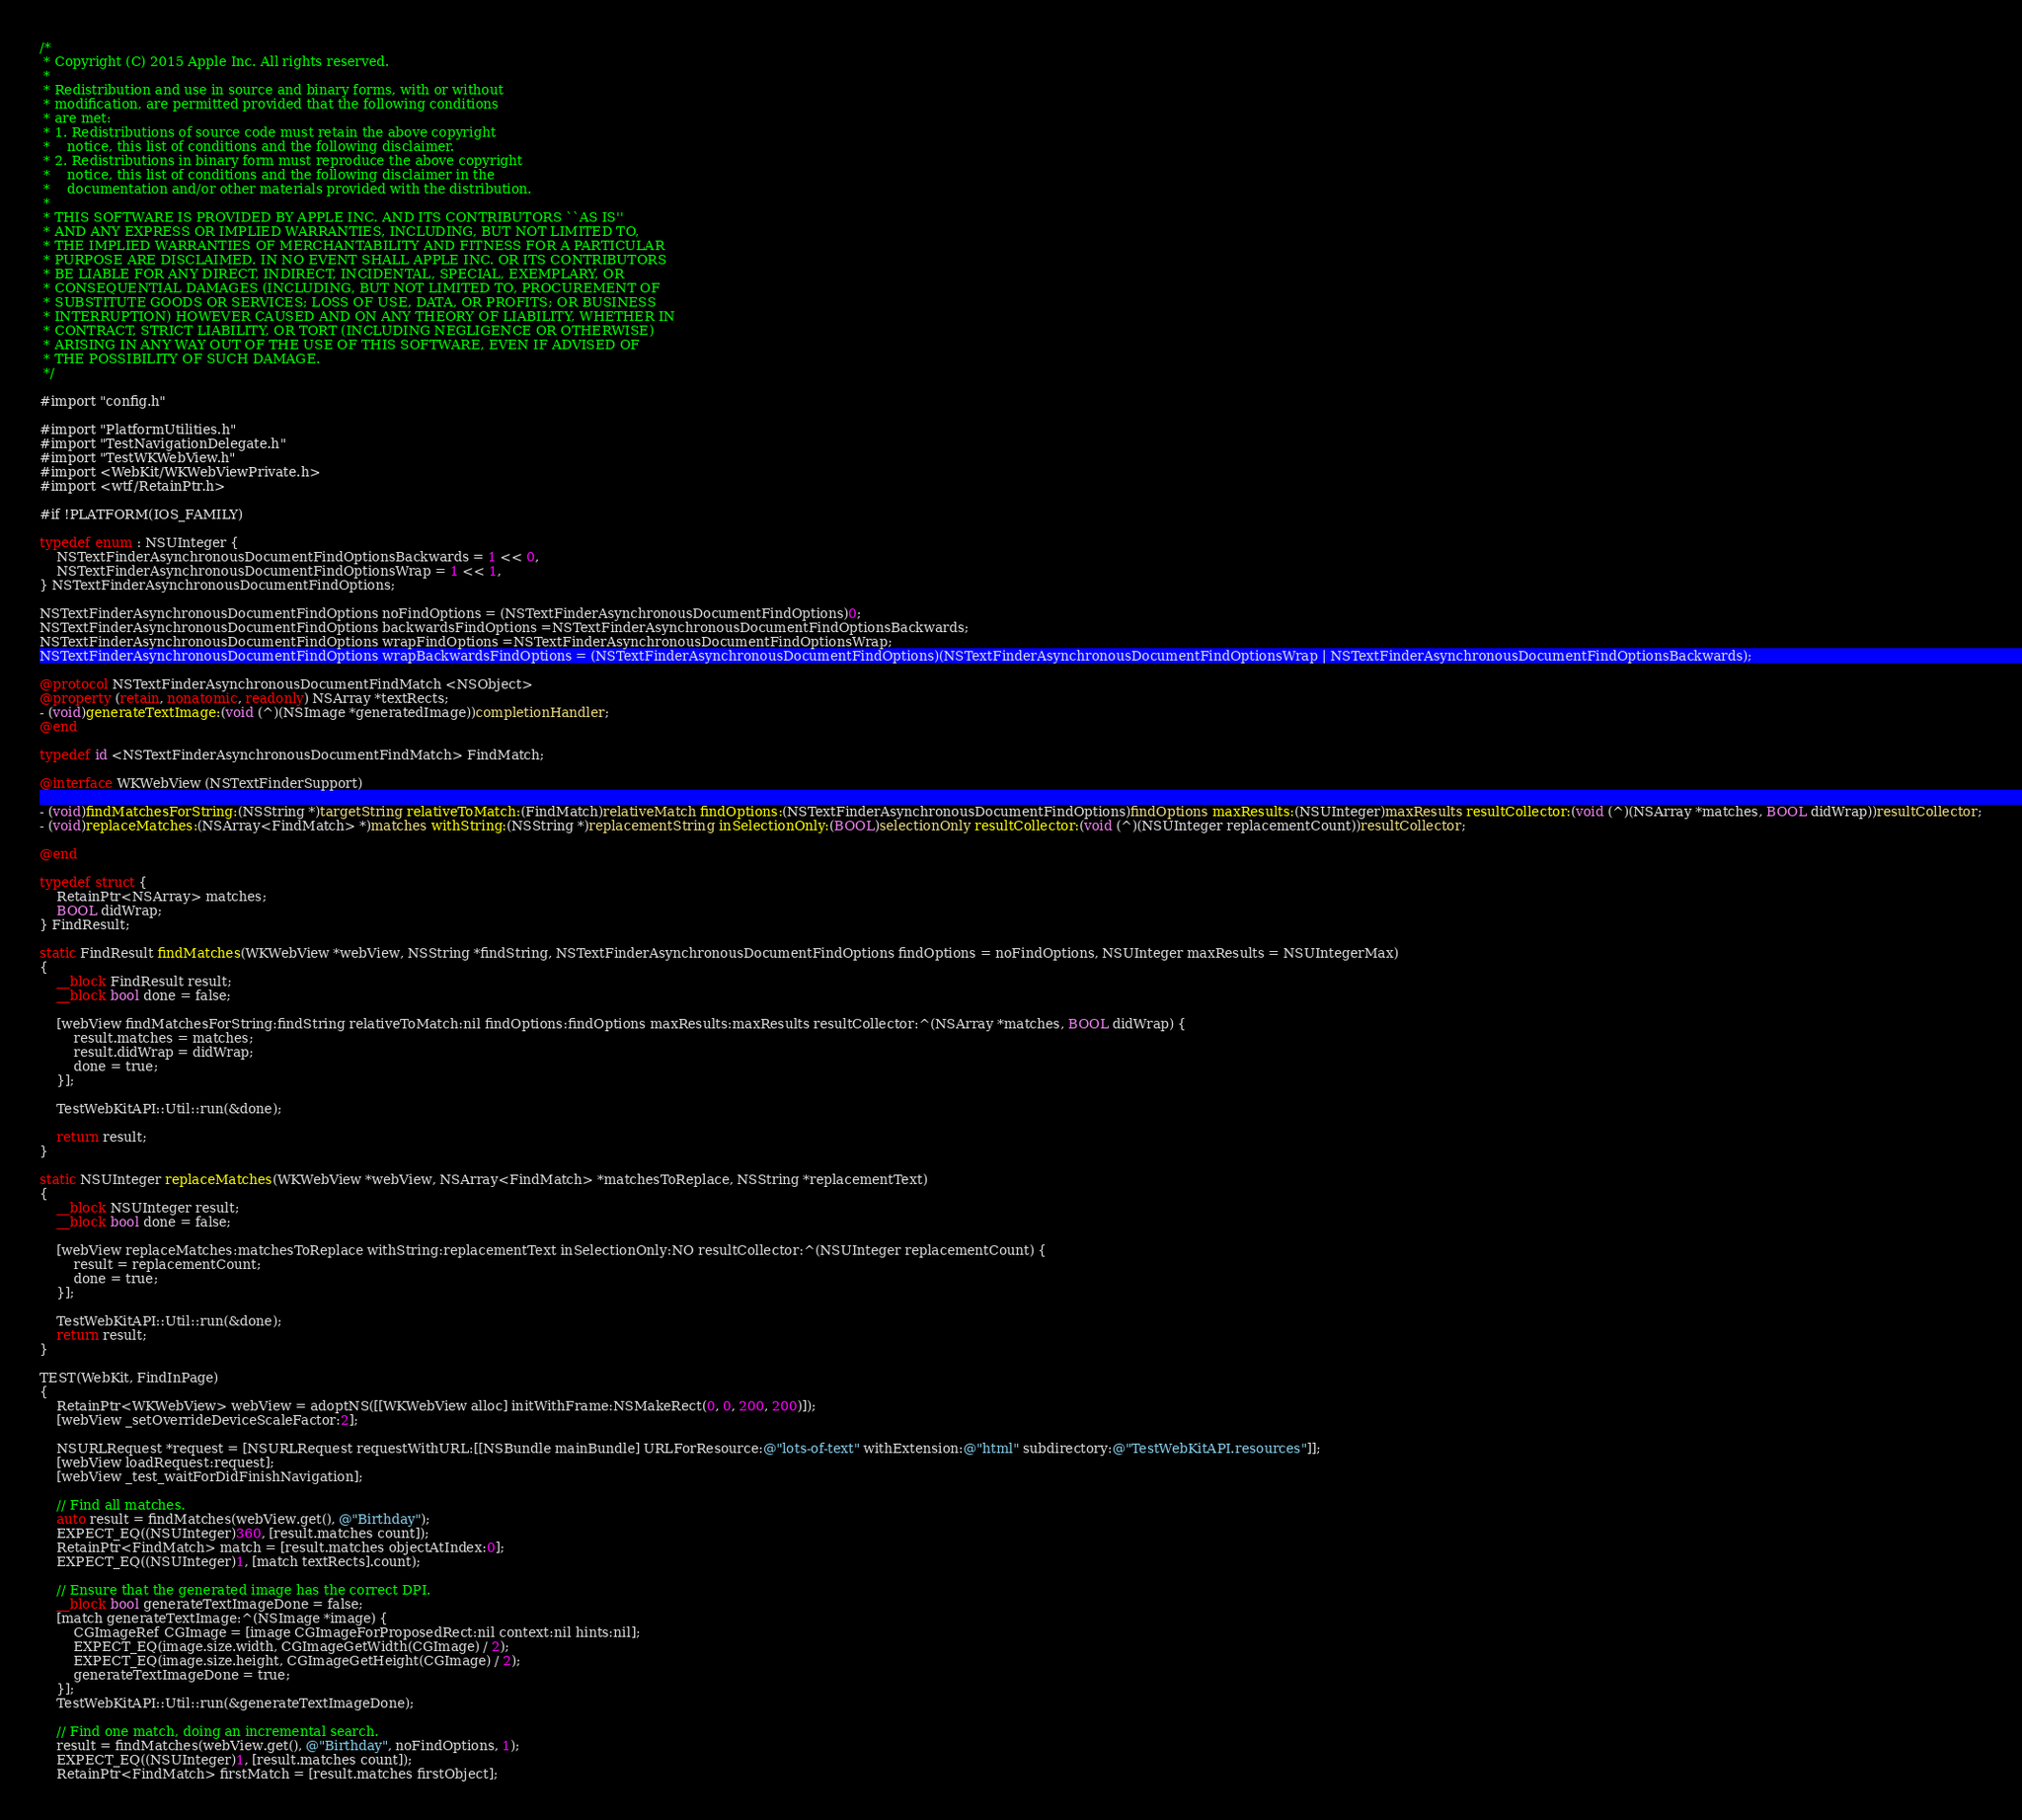Convert code to text. <code><loc_0><loc_0><loc_500><loc_500><_ObjectiveC_>/*
 * Copyright (C) 2015 Apple Inc. All rights reserved.
 *
 * Redistribution and use in source and binary forms, with or without
 * modification, are permitted provided that the following conditions
 * are met:
 * 1. Redistributions of source code must retain the above copyright
 *    notice, this list of conditions and the following disclaimer.
 * 2. Redistributions in binary form must reproduce the above copyright
 *    notice, this list of conditions and the following disclaimer in the
 *    documentation and/or other materials provided with the distribution.
 *
 * THIS SOFTWARE IS PROVIDED BY APPLE INC. AND ITS CONTRIBUTORS ``AS IS''
 * AND ANY EXPRESS OR IMPLIED WARRANTIES, INCLUDING, BUT NOT LIMITED TO,
 * THE IMPLIED WARRANTIES OF MERCHANTABILITY AND FITNESS FOR A PARTICULAR
 * PURPOSE ARE DISCLAIMED. IN NO EVENT SHALL APPLE INC. OR ITS CONTRIBUTORS
 * BE LIABLE FOR ANY DIRECT, INDIRECT, INCIDENTAL, SPECIAL, EXEMPLARY, OR
 * CONSEQUENTIAL DAMAGES (INCLUDING, BUT NOT LIMITED TO, PROCUREMENT OF
 * SUBSTITUTE GOODS OR SERVICES; LOSS OF USE, DATA, OR PROFITS; OR BUSINESS
 * INTERRUPTION) HOWEVER CAUSED AND ON ANY THEORY OF LIABILITY, WHETHER IN
 * CONTRACT, STRICT LIABILITY, OR TORT (INCLUDING NEGLIGENCE OR OTHERWISE)
 * ARISING IN ANY WAY OUT OF THE USE OF THIS SOFTWARE, EVEN IF ADVISED OF
 * THE POSSIBILITY OF SUCH DAMAGE.
 */

#import "config.h"

#import "PlatformUtilities.h"
#import "TestNavigationDelegate.h"
#import "TestWKWebView.h"
#import <WebKit/WKWebViewPrivate.h>
#import <wtf/RetainPtr.h>

#if !PLATFORM(IOS_FAMILY)

typedef enum : NSUInteger {
    NSTextFinderAsynchronousDocumentFindOptionsBackwards = 1 << 0,
    NSTextFinderAsynchronousDocumentFindOptionsWrap = 1 << 1,
} NSTextFinderAsynchronousDocumentFindOptions;

NSTextFinderAsynchronousDocumentFindOptions noFindOptions = (NSTextFinderAsynchronousDocumentFindOptions)0;
NSTextFinderAsynchronousDocumentFindOptions backwardsFindOptions =NSTextFinderAsynchronousDocumentFindOptionsBackwards;
NSTextFinderAsynchronousDocumentFindOptions wrapFindOptions =NSTextFinderAsynchronousDocumentFindOptionsWrap;
NSTextFinderAsynchronousDocumentFindOptions wrapBackwardsFindOptions = (NSTextFinderAsynchronousDocumentFindOptions)(NSTextFinderAsynchronousDocumentFindOptionsWrap | NSTextFinderAsynchronousDocumentFindOptionsBackwards);

@protocol NSTextFinderAsynchronousDocumentFindMatch <NSObject>
@property (retain, nonatomic, readonly) NSArray *textRects;
- (void)generateTextImage:(void (^)(NSImage *generatedImage))completionHandler;
@end

typedef id <NSTextFinderAsynchronousDocumentFindMatch> FindMatch;

@interface WKWebView (NSTextFinderSupport)

- (void)findMatchesForString:(NSString *)targetString relativeToMatch:(FindMatch)relativeMatch findOptions:(NSTextFinderAsynchronousDocumentFindOptions)findOptions maxResults:(NSUInteger)maxResults resultCollector:(void (^)(NSArray *matches, BOOL didWrap))resultCollector;
- (void)replaceMatches:(NSArray<FindMatch> *)matches withString:(NSString *)replacementString inSelectionOnly:(BOOL)selectionOnly resultCollector:(void (^)(NSUInteger replacementCount))resultCollector;

@end

typedef struct {
    RetainPtr<NSArray> matches;
    BOOL didWrap;
} FindResult;

static FindResult findMatches(WKWebView *webView, NSString *findString, NSTextFinderAsynchronousDocumentFindOptions findOptions = noFindOptions, NSUInteger maxResults = NSUIntegerMax)
{
    __block FindResult result;
    __block bool done = false;

    [webView findMatchesForString:findString relativeToMatch:nil findOptions:findOptions maxResults:maxResults resultCollector:^(NSArray *matches, BOOL didWrap) {
        result.matches = matches;
        result.didWrap = didWrap;
        done = true;
    }];

    TestWebKitAPI::Util::run(&done);

    return result;
}

static NSUInteger replaceMatches(WKWebView *webView, NSArray<FindMatch> *matchesToReplace, NSString *replacementText)
{
    __block NSUInteger result;
    __block bool done = false;

    [webView replaceMatches:matchesToReplace withString:replacementText inSelectionOnly:NO resultCollector:^(NSUInteger replacementCount) {
        result = replacementCount;
        done = true;
    }];

    TestWebKitAPI::Util::run(&done);
    return result;
}

TEST(WebKit, FindInPage)
{
    RetainPtr<WKWebView> webView = adoptNS([[WKWebView alloc] initWithFrame:NSMakeRect(0, 0, 200, 200)]);
    [webView _setOverrideDeviceScaleFactor:2];

    NSURLRequest *request = [NSURLRequest requestWithURL:[[NSBundle mainBundle] URLForResource:@"lots-of-text" withExtension:@"html" subdirectory:@"TestWebKitAPI.resources"]];
    [webView loadRequest:request];
    [webView _test_waitForDidFinishNavigation];

    // Find all matches.
    auto result = findMatches(webView.get(), @"Birthday");
    EXPECT_EQ((NSUInteger)360, [result.matches count]);
    RetainPtr<FindMatch> match = [result.matches objectAtIndex:0];
    EXPECT_EQ((NSUInteger)1, [match textRects].count);

    // Ensure that the generated image has the correct DPI.
    __block bool generateTextImageDone = false;
    [match generateTextImage:^(NSImage *image) {
        CGImageRef CGImage = [image CGImageForProposedRect:nil context:nil hints:nil];
        EXPECT_EQ(image.size.width, CGImageGetWidth(CGImage) / 2);
        EXPECT_EQ(image.size.height, CGImageGetHeight(CGImage) / 2);
        generateTextImageDone = true;
    }];
    TestWebKitAPI::Util::run(&generateTextImageDone);

    // Find one match, doing an incremental search.
    result = findMatches(webView.get(), @"Birthday", noFindOptions, 1);
    EXPECT_EQ((NSUInteger)1, [result.matches count]);
    RetainPtr<FindMatch> firstMatch = [result.matches firstObject];</code> 